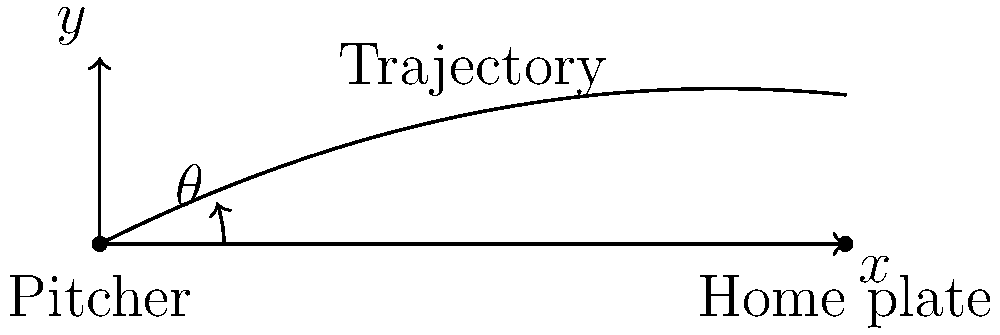As a baseball pitching coach, you want to calculate the optimal angle $\theta$ for a pitch to reach home plate, which is 60 feet away. The desired trajectory of the pitch follows the equation $y = -0.005x^2 + 0.5x$, where $x$ is the horizontal distance and $y$ is the height. What is the optimal angle $\theta$ in degrees for the pitcher to release the ball? To find the optimal angle $\theta$, we need to follow these steps:

1) The trajectory is given by the equation $y = -0.005x^2 + 0.5x$.

2) To find the angle at the starting point (where the pitcher releases the ball), we need to calculate the slope of the tangent line at $x = 0$.

3) The slope of the tangent line at any point is given by the derivative of the function:
   $\frac{dy}{dx} = -0.01x + 0.5$

4) At $x = 0$, the slope is:
   $\frac{dy}{dx}|_{x=0} = 0.5$

5) The angle $\theta$ is related to this slope by the tangent function:
   $\tan(\theta) = 0.5$

6) To find $\theta$, we take the inverse tangent (arctangent):
   $\theta = \arctan(0.5)$

7) Convert this to degrees:
   $\theta = \arctan(0.5) \cdot \frac{180}{\pi}$

8) Calculating this gives us approximately 26.57 degrees.
Answer: $26.57^\circ$ 